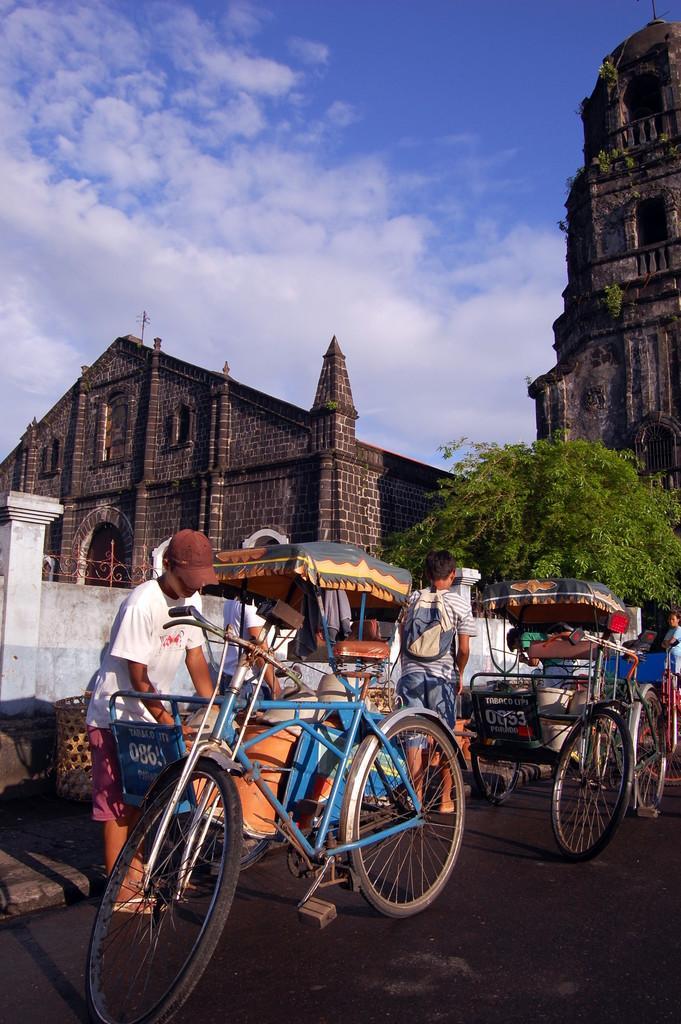In one or two sentences, can you explain what this image depicts? In this image, we can see some people and rickshaws on the road and in the background, there are buildings and trees. At the top, there are clouds in the sky. 